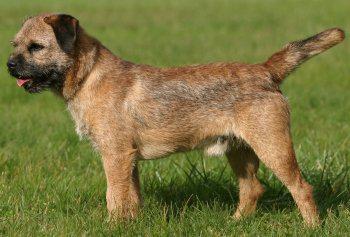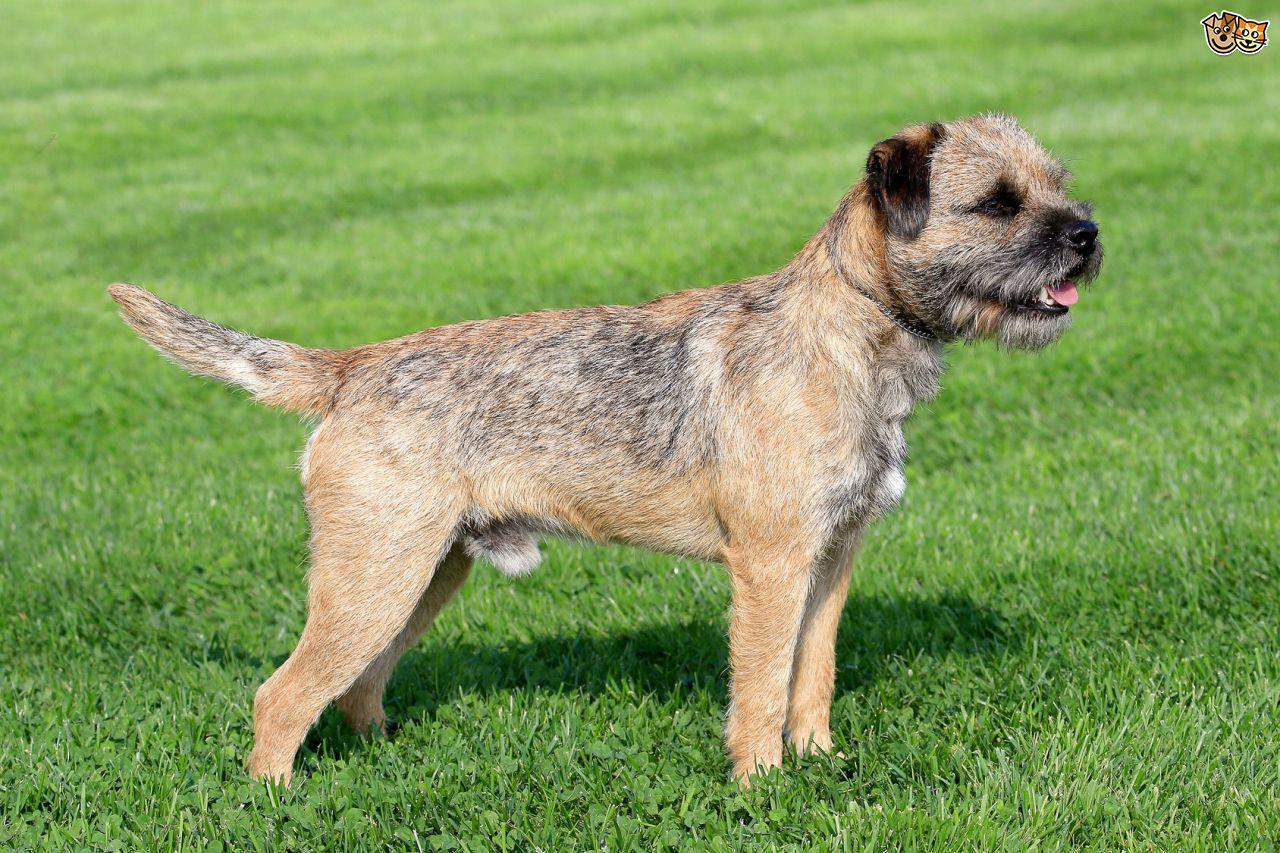The first image is the image on the left, the second image is the image on the right. Given the left and right images, does the statement "One of the dogs has its tongue visible without its teeth showing." hold true? Answer yes or no. Yes. The first image is the image on the left, the second image is the image on the right. Evaluate the accuracy of this statement regarding the images: "A single dog is standing on all fours in the image on the left.". Is it true? Answer yes or no. Yes. The first image is the image on the left, the second image is the image on the right. For the images displayed, is the sentence "All images show one dog that is standing." factually correct? Answer yes or no. Yes. The first image is the image on the left, the second image is the image on the right. Examine the images to the left and right. Is the description "One of the dogs is facing directly toward the left." accurate? Answer yes or no. Yes. The first image is the image on the left, the second image is the image on the right. Analyze the images presented: Is the assertion "At least one dog in the left image is looking towards the left." valid? Answer yes or no. Yes. 